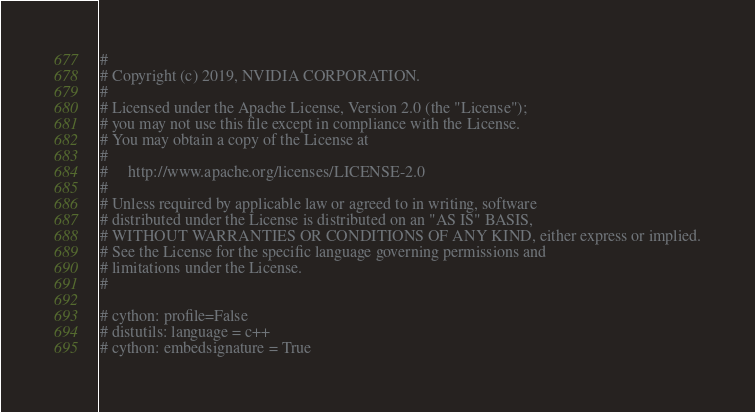Convert code to text. <code><loc_0><loc_0><loc_500><loc_500><_Cython_>#
# Copyright (c) 2019, NVIDIA CORPORATION.
#
# Licensed under the Apache License, Version 2.0 (the "License");
# you may not use this file except in compliance with the License.
# You may obtain a copy of the License at
#
#     http://www.apache.org/licenses/LICENSE-2.0
#
# Unless required by applicable law or agreed to in writing, software
# distributed under the License is distributed on an "AS IS" BASIS,
# WITHOUT WARRANTIES OR CONDITIONS OF ANY KIND, either express or implied.
# See the License for the specific language governing permissions and
# limitations under the License.
#

# cython: profile=False
# distutils: language = c++
# cython: embedsignature = True</code> 